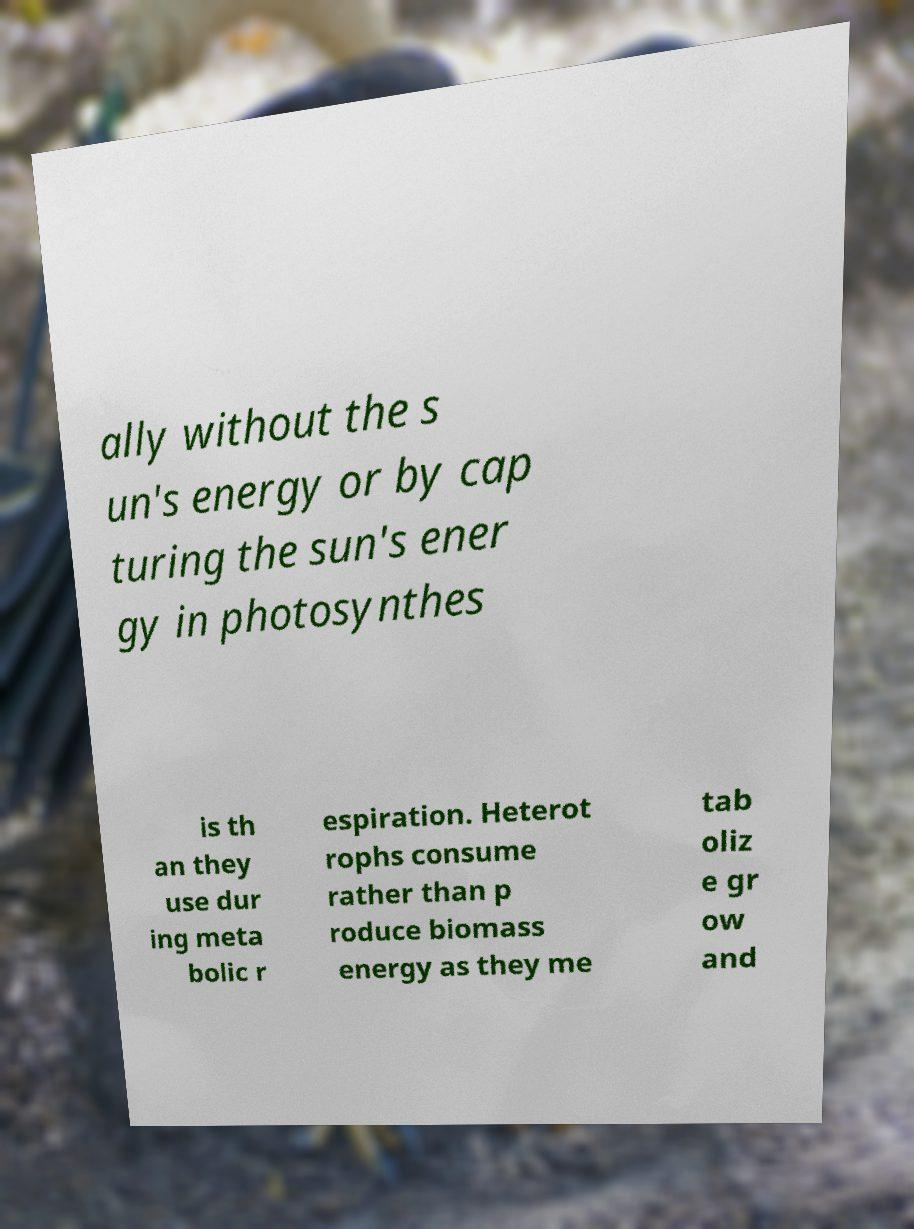Could you extract and type out the text from this image? ally without the s un's energy or by cap turing the sun's ener gy in photosynthes is th an they use dur ing meta bolic r espiration. Heterot rophs consume rather than p roduce biomass energy as they me tab oliz e gr ow and 